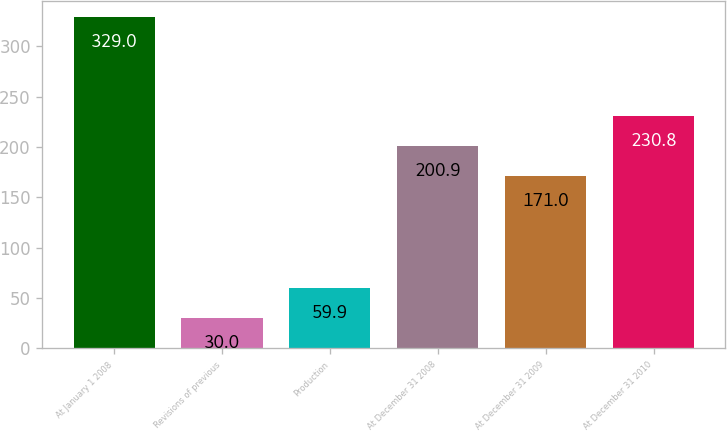Convert chart. <chart><loc_0><loc_0><loc_500><loc_500><bar_chart><fcel>At January 1 2008<fcel>Revisions of previous<fcel>Production<fcel>At December 31 2008<fcel>At December 31 2009<fcel>At December 31 2010<nl><fcel>329<fcel>30<fcel>59.9<fcel>200.9<fcel>171<fcel>230.8<nl></chart> 